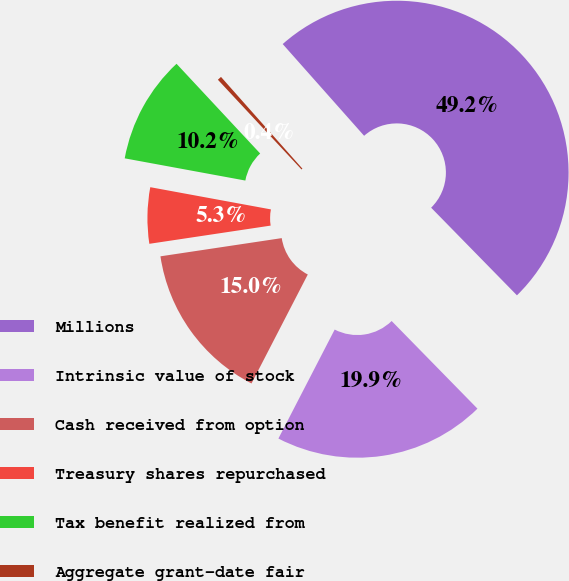Convert chart to OTSL. <chart><loc_0><loc_0><loc_500><loc_500><pie_chart><fcel>Millions<fcel>Intrinsic value of stock<fcel>Cash received from option<fcel>Treasury shares repurchased<fcel>Tax benefit realized from<fcel>Aggregate grant-date fair<nl><fcel>49.22%<fcel>19.92%<fcel>15.04%<fcel>5.27%<fcel>10.16%<fcel>0.39%<nl></chart> 